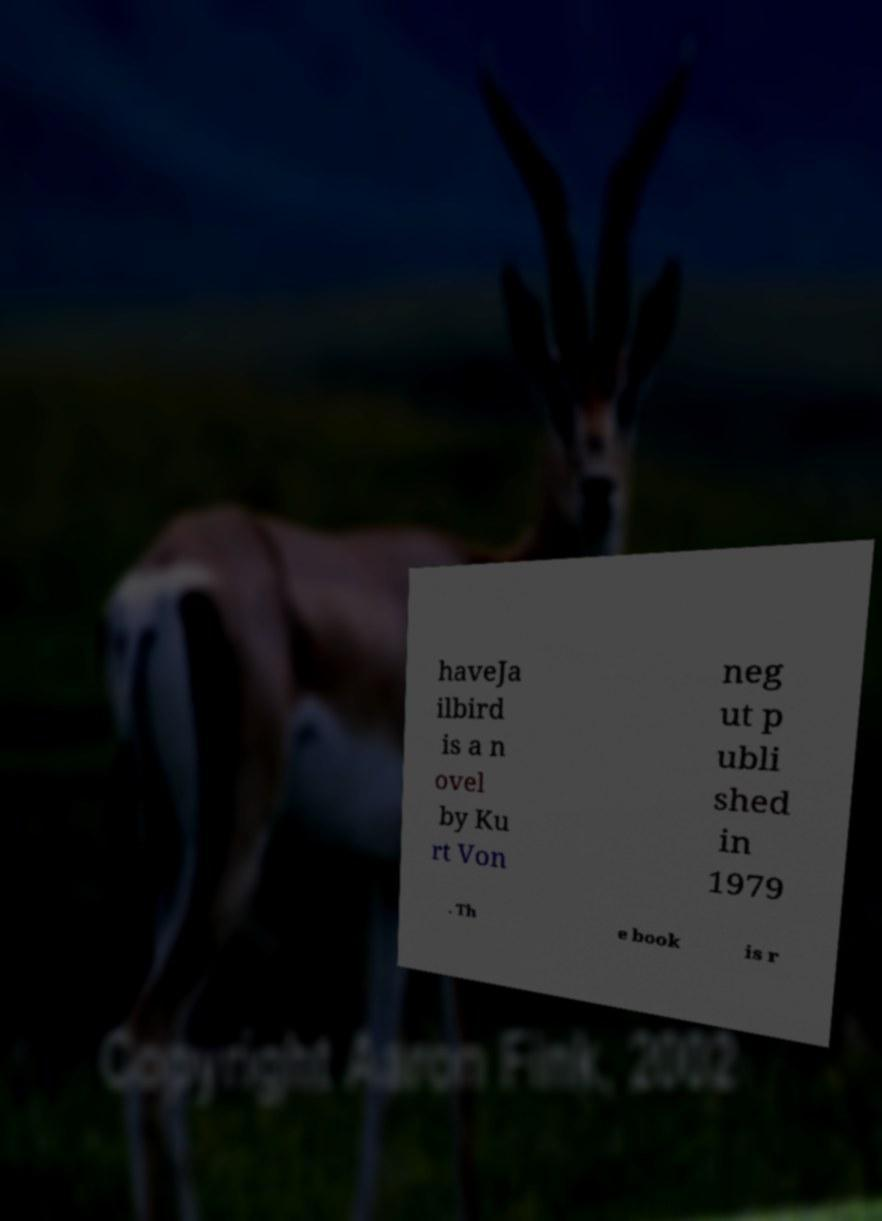For documentation purposes, I need the text within this image transcribed. Could you provide that? haveJa ilbird is a n ovel by Ku rt Von neg ut p ubli shed in 1979 . Th e book is r 